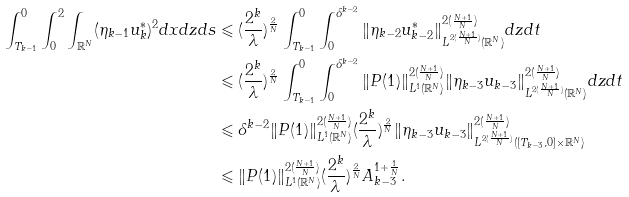Convert formula to latex. <formula><loc_0><loc_0><loc_500><loc_500>\int _ { T _ { k - 1 } } ^ { 0 } \int _ { 0 } ^ { 2 } \int _ { \mathbb { R } ^ { N } } ( \eta _ { k - 1 } u _ { k } ^ { * } ) ^ { 2 } d x d z d s & \leqslant ( \frac { 2 ^ { k } } { \lambda } ) ^ { \frac { 2 } { N } } \int _ { T _ { k - 1 } } ^ { 0 } \int _ { 0 } ^ { \delta ^ { k - 2 } } \| \eta _ { k - 2 } u _ { k - 2 } ^ { * } \| _ { L ^ { 2 ( \frac { N + 1 } { N } ) } ( \mathbb { R } ^ { N } ) } ^ { 2 ( \frac { N + 1 } { N } ) } d z d t \\ & \leqslant ( \frac { 2 ^ { k } } { \lambda } ) ^ { \frac { 2 } { N } } \int _ { T _ { k - 1 } } ^ { 0 } \int _ { 0 } ^ { \delta ^ { k - 2 } } \| P ( 1 ) \| _ { L ^ { 1 } ( \mathbb { R } ^ { N } ) } ^ { 2 ( \frac { N + 1 } { N } ) } \| \eta _ { k - 3 } u _ { k - 3 } \| _ { L ^ { 2 ( \frac { N + 1 } { N } ) } ( \mathbb { R } ^ { N } ) } ^ { 2 ( \frac { N + 1 } { N } ) } d z d t \\ & \leqslant \delta ^ { k - 2 } \| P ( 1 ) \| _ { L ^ { 1 } ( \mathbb { R } ^ { N } ) } ^ { 2 ( \frac { N + 1 } { N } ) } ( \frac { 2 ^ { k } } { \lambda } ) ^ { \frac { 2 } { N } } \| \eta _ { k - 3 } u _ { k - 3 } \| _ { L ^ { 2 ( \frac { N + 1 } { N } ) } ( [ T _ { k - 3 } , 0 ] \times \mathbb { R } ^ { N } ) } ^ { 2 ( \frac { N + 1 } { N } ) } \\ & \leqslant \| P ( 1 ) \| _ { L ^ { 1 } ( \mathbb { R } ^ { N } ) } ^ { 2 ( \frac { N + 1 } { N } ) } ( \frac { 2 ^ { k } } { \lambda } ) ^ { \frac { 2 } { N } } A _ { k - 3 } ^ { 1 + \frac { 1 } { N } } .</formula> 